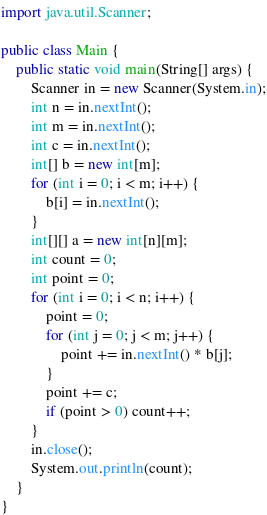<code> <loc_0><loc_0><loc_500><loc_500><_Java_>import java.util.Scanner;

public class Main {
    public static void main(String[] args) {
        Scanner in = new Scanner(System.in);
        int n = in.nextInt();
        int m = in.nextInt();
        int c = in.nextInt();
        int[] b = new int[m];
        for (int i = 0; i < m; i++) {
            b[i] = in.nextInt();
        }
        int[][] a = new int[n][m];
        int count = 0;
        int point = 0;
        for (int i = 0; i < n; i++) {
            point = 0;
            for (int j = 0; j < m; j++) {
                point += in.nextInt() * b[j];
            }
            point += c;
            if (point > 0) count++;
        }
        in.close();
        System.out.println(count);
    }
}
</code> 